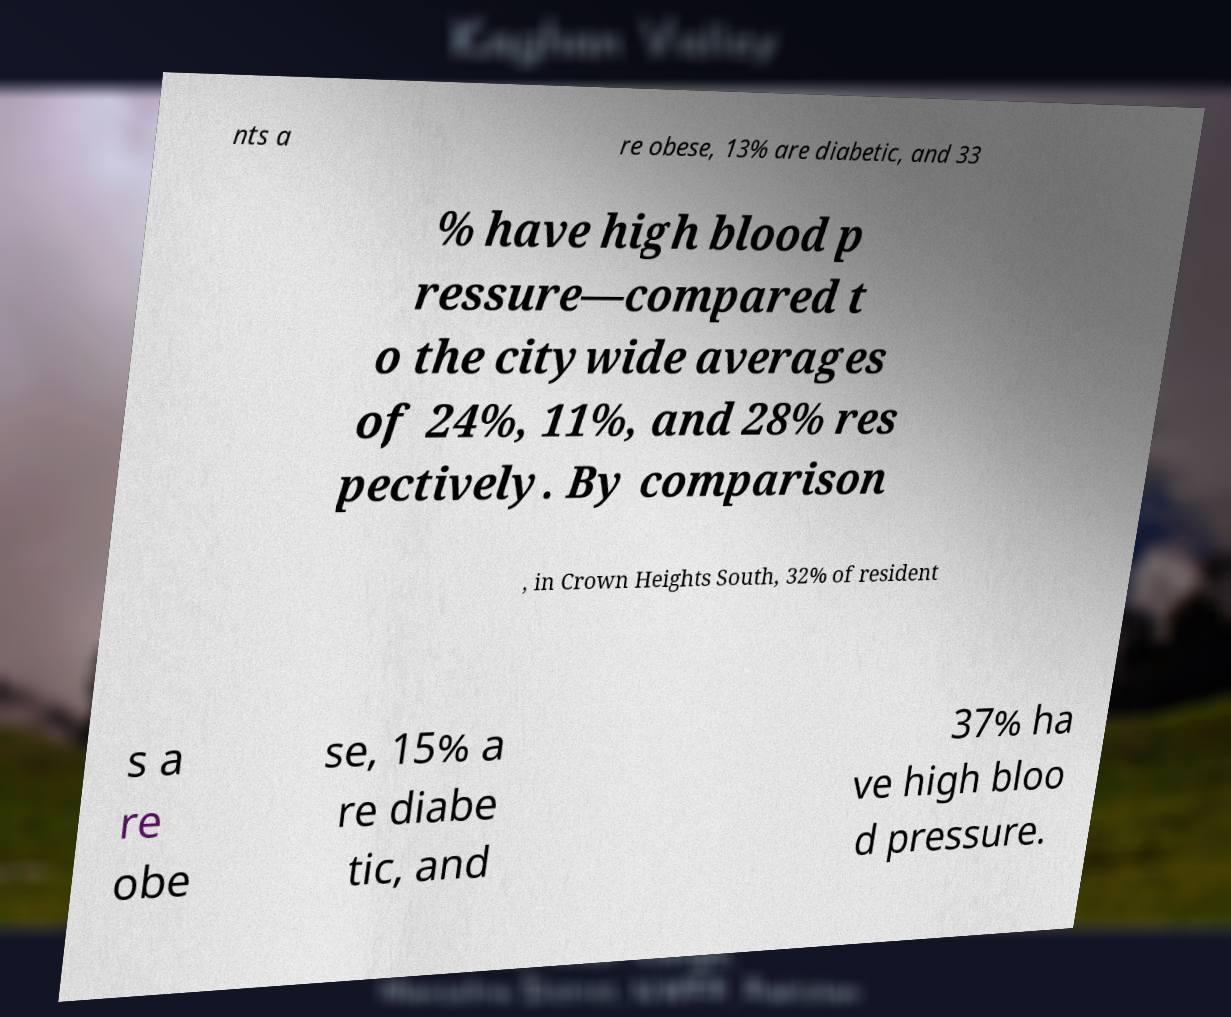Could you extract and type out the text from this image? nts a re obese, 13% are diabetic, and 33 % have high blood p ressure—compared t o the citywide averages of 24%, 11%, and 28% res pectively. By comparison , in Crown Heights South, 32% of resident s a re obe se, 15% a re diabe tic, and 37% ha ve high bloo d pressure. 